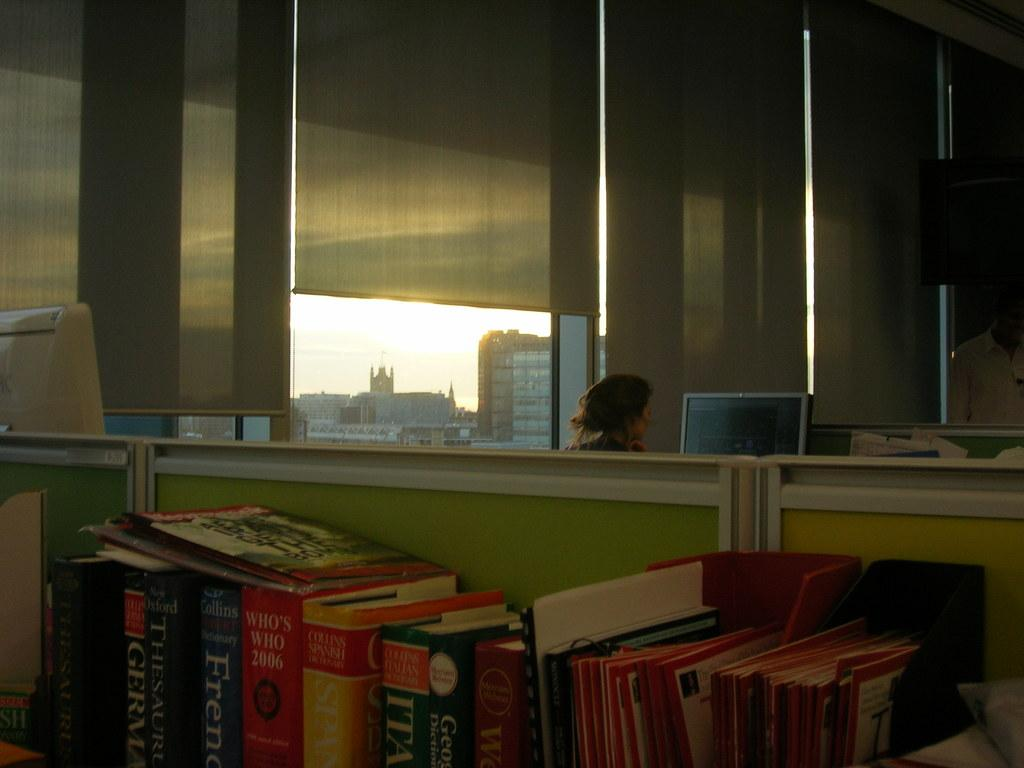<image>
Summarize the visual content of the image. A variety of books from Collins in various languages. 